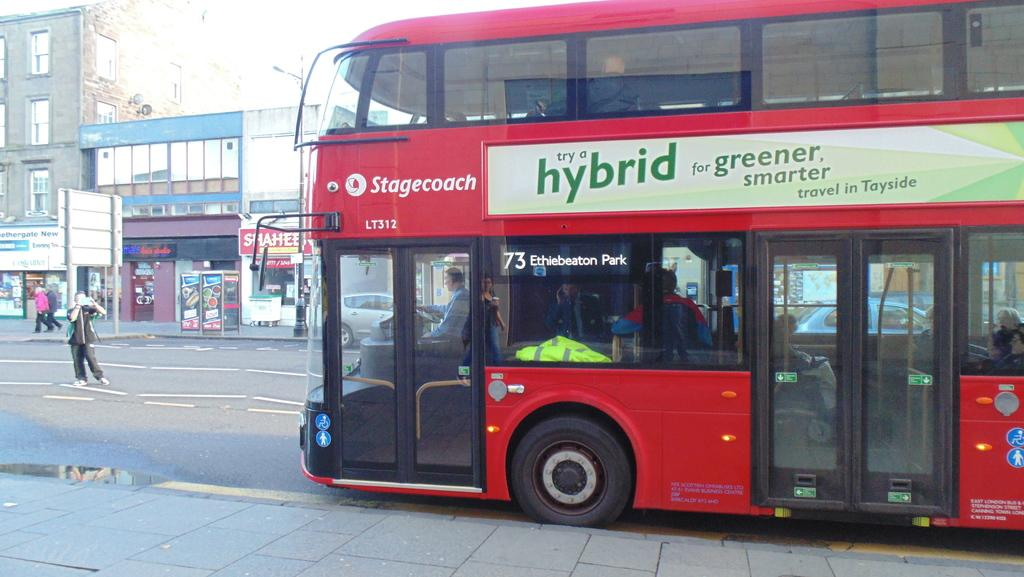What is located in the foreground of the picture? There is a payment and a bus in the foreground of the picture. What can be seen on the left side of the picture? There are buildings, a pavement, hoardings, and people on the left side of the picture. What type of surface is present on the left side of the picture? There is a pavement on the left side of the picture. What is the weather like in the image? The weather is sunny in the image. How many sticks are being used by the people on the left side of the picture? There are no sticks present in the image; the people are not using any sticks. What type of town is depicted in the image? The image does not depict a town; it shows a bus, buildings, and people on the left side of the picture. 